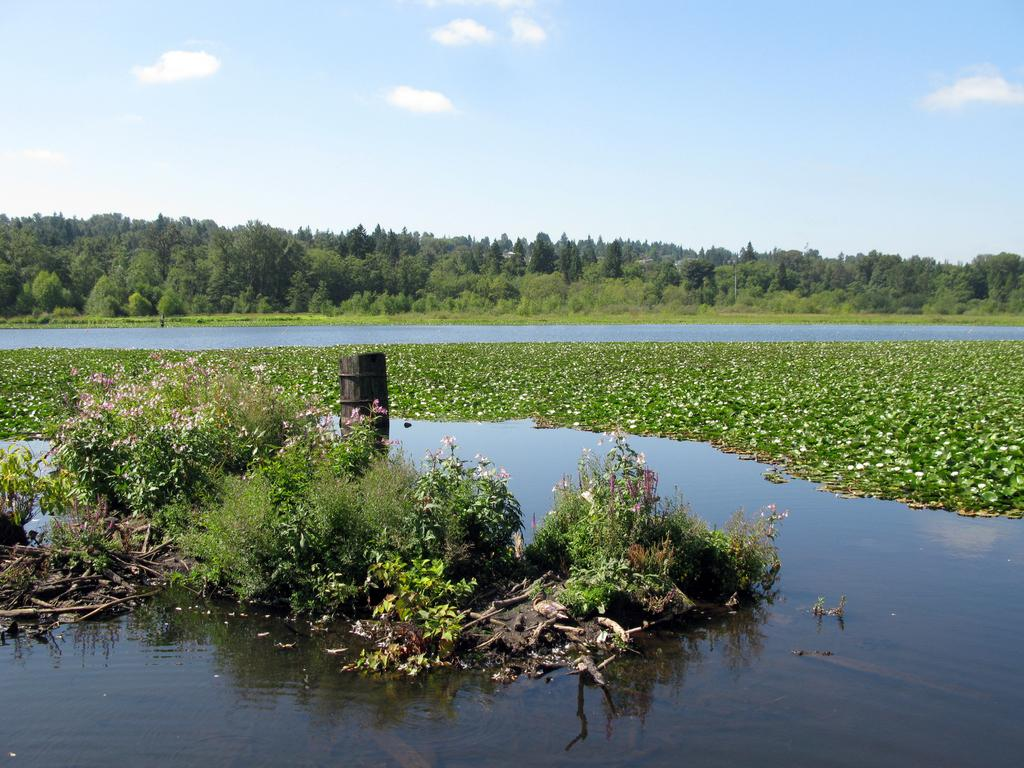What type of body of water is present in the image? There is a lake in the picture. What can be seen in the middle of the picture? There are plants in the middle of the picture. What is visible in the background of the picture? There are trees and the sky visible in the background of the picture. What time does the clock show in the image? There is no clock present in the image. How many potatoes can be seen growing in the lake? There are no potatoes visible in the image; it features a lake with plants in the middle. 